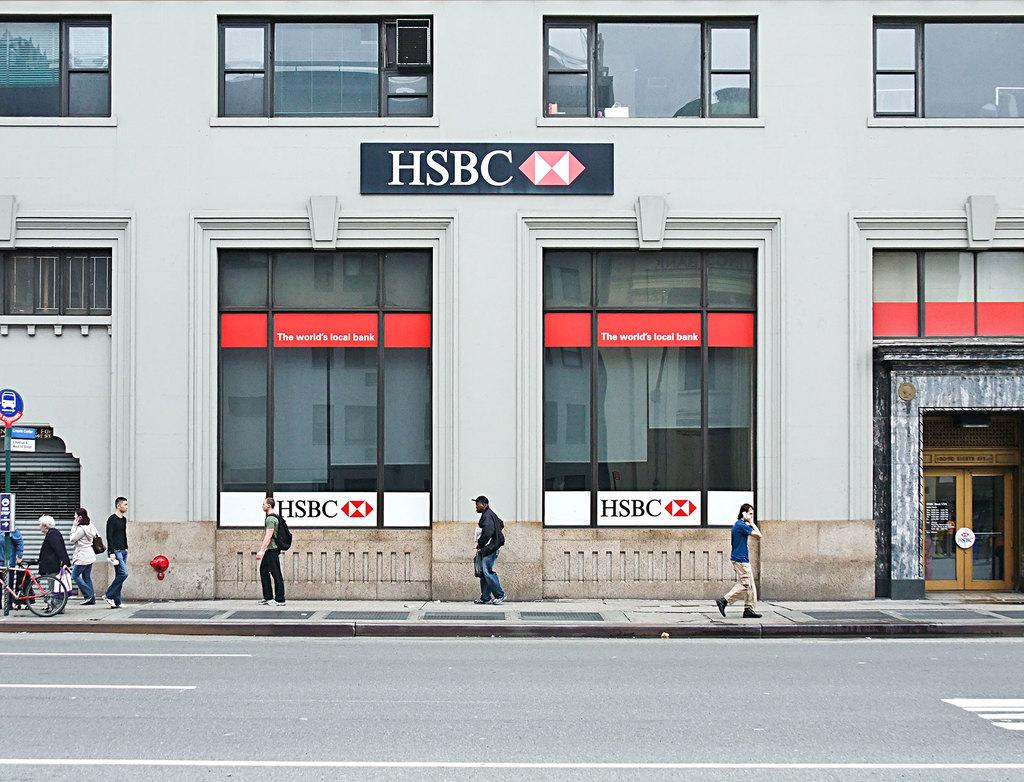<image>
Provide a brief description of the given image. Several people are walking past a branch of HSCB bank. 